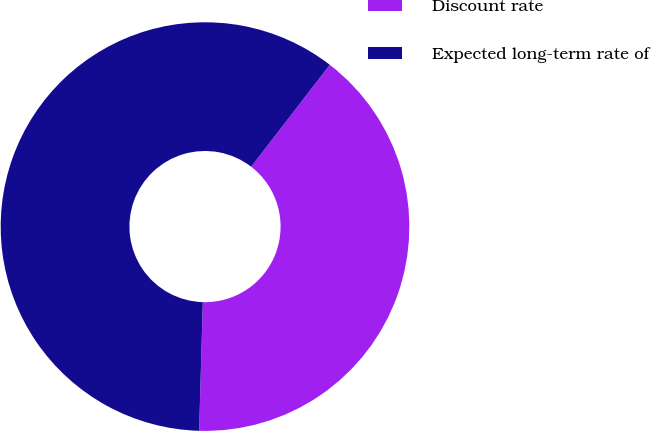Convert chart. <chart><loc_0><loc_0><loc_500><loc_500><pie_chart><fcel>Discount rate<fcel>Expected long-term rate of<nl><fcel>40.0%<fcel>60.0%<nl></chart> 